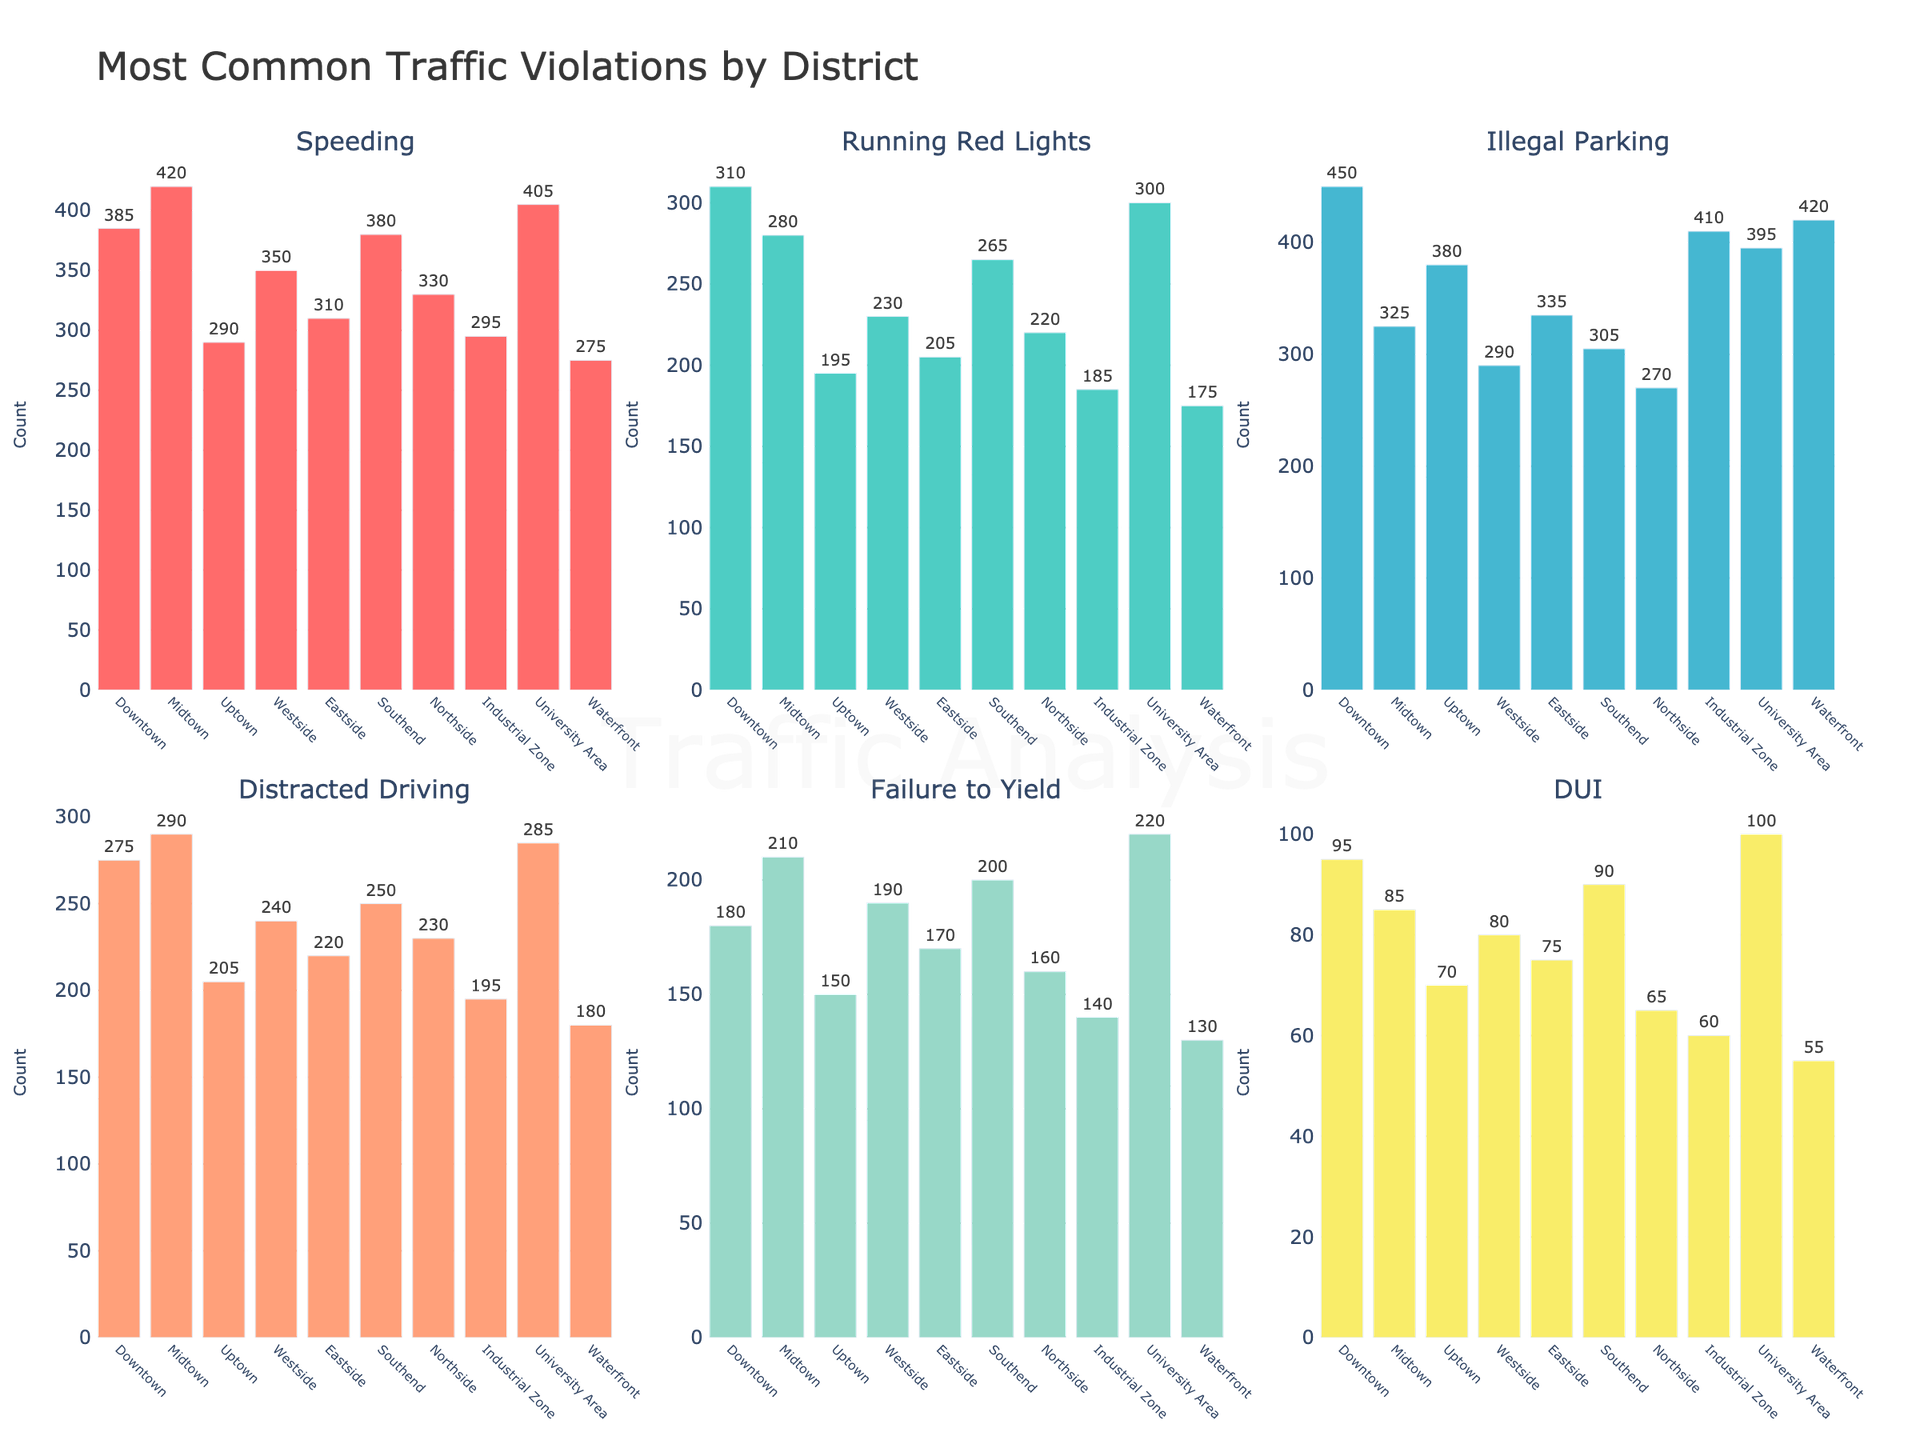What's the most common traffic violation in Downtown? The bar for Illegal Parking in Downtown is the highest among all violations for this district.
Answer: Illegal Parking Which district has the highest number of Speeding violations? The bar for Speeding in Midtown is the highest among all other districts.
Answer: Midtown What's the difference between the number of Running Red Lights incidents in Downtown and Uptown? The bar for Running Red Lights in Downtown shows 310 incidents, while Uptown has 195. The difference is 310 - 195.
Answer: 115 Which two districts have the closest numbers of Failure to Yield violations, and what are those numbers? Both Westside and Eastside have visually similar bars for Failure to Yield, showing 190 and 170 violations respectively.
Answer: Westside and Eastside, 190 and 170 Which violation category has the most uniform distribution across all districts? The bar lengths for DUI violations appear to be the most uniformly distributed across all districts, without a single district dominating significantly higher than others.
Answer: DUI What’s the sum of Illegal Parking violations in the Downtown and Midtown districts? Downtown has 450 and Midtown has 325 Illegal Parking violations. Adding them gives 450 + 325.
Answer: 775 How much higher is the count of Distracted Driving incidents in University Area compared to the Industrial Zone? The University Area has 285 Distracted Driving incidents, and the Industrial Zone has 195. Subtracting these gives 285 - 195.
Answer: 90 In which district does the bar for DUI violations appear the shortest, and what's the count? The Waterfront district has the shortest bar for DUI, showing 55 violations.
Answer: Waterfront, 55 What is the average number of Speeding violations across all districts? Summing the counts of Speeding across all districts [385, 420, 290, 350, 310, 380, 330, 295, 405, 275] and dividing by the number of districts (10) gives (3840/10).
Answer: 384 Which district has a higher number of Total violations considering all categories, the Southend or Northside? Summing up violations in Southend [380+265+305+250+200+90=1490] and Northside [330+220+270+230+160+65=1275], Southend has a higher total.
Answer: Southend Who has the lowest count of Running Red Lights violations? The Waterfront district, as its bar for Running Red Lights is the shortest, showing 175.
Answer: Waterfront 